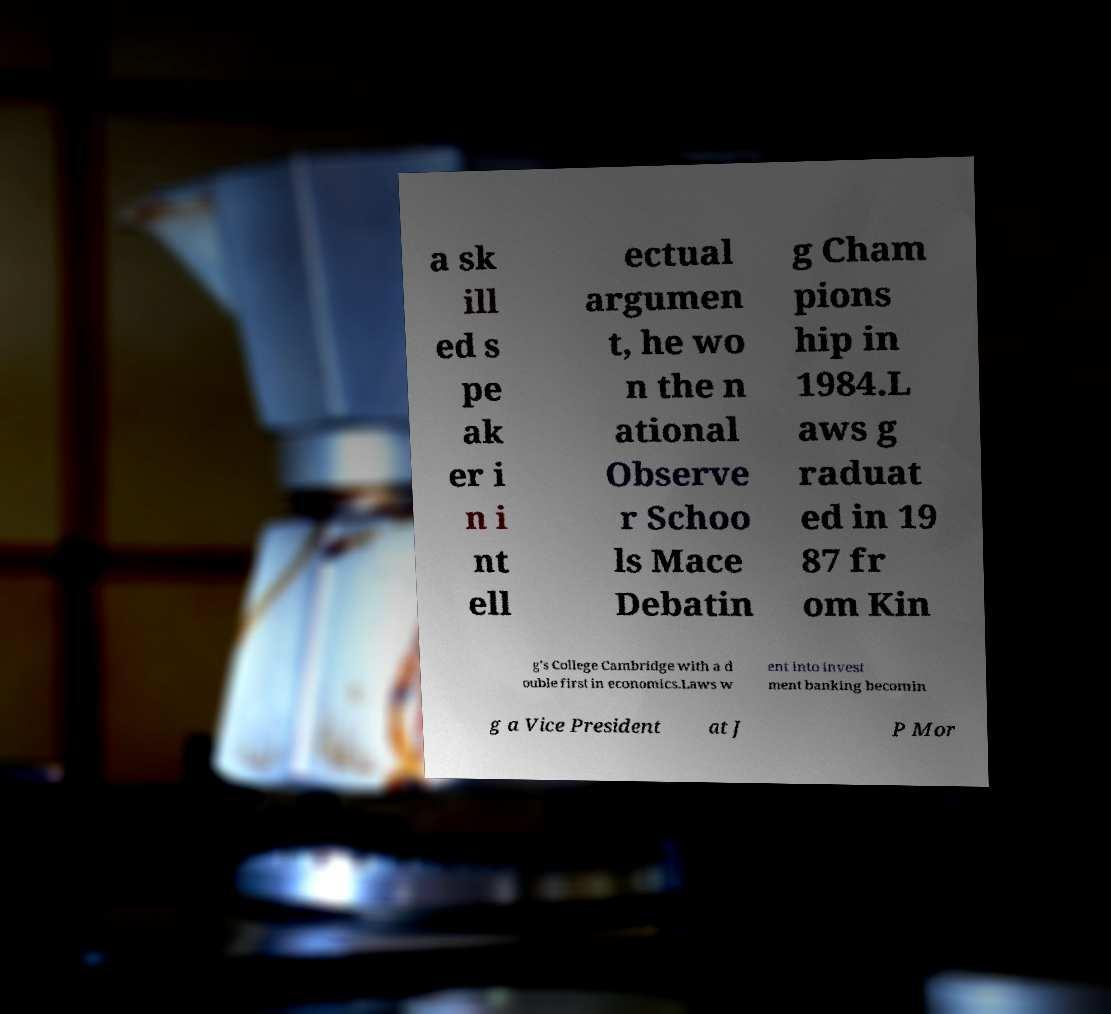For documentation purposes, I need the text within this image transcribed. Could you provide that? a sk ill ed s pe ak er i n i nt ell ectual argumen t, he wo n the n ational Observe r Schoo ls Mace Debatin g Cham pions hip in 1984.L aws g raduat ed in 19 87 fr om Kin g's College Cambridge with a d ouble first in economics.Laws w ent into invest ment banking becomin g a Vice President at J P Mor 